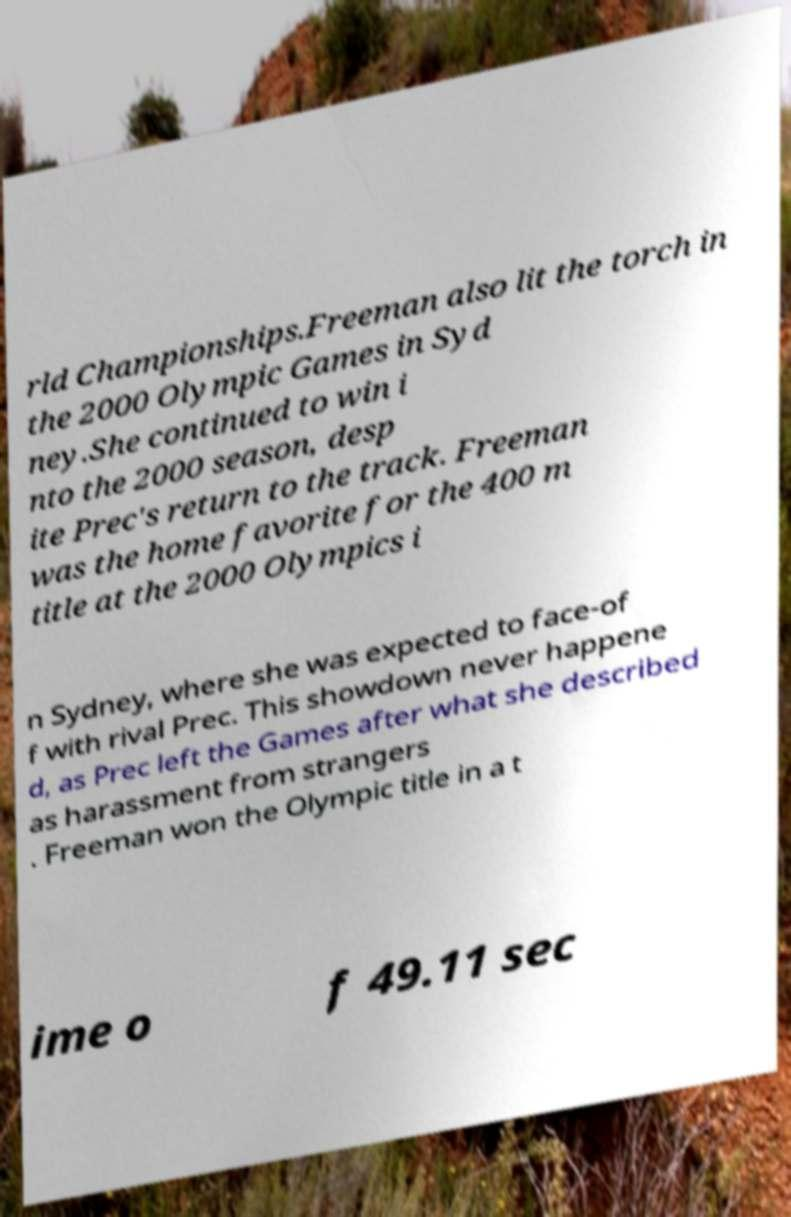What messages or text are displayed in this image? I need them in a readable, typed format. rld Championships.Freeman also lit the torch in the 2000 Olympic Games in Syd ney.She continued to win i nto the 2000 season, desp ite Prec's return to the track. Freeman was the home favorite for the 400 m title at the 2000 Olympics i n Sydney, where she was expected to face-of f with rival Prec. This showdown never happene d, as Prec left the Games after what she described as harassment from strangers . Freeman won the Olympic title in a t ime o f 49.11 sec 